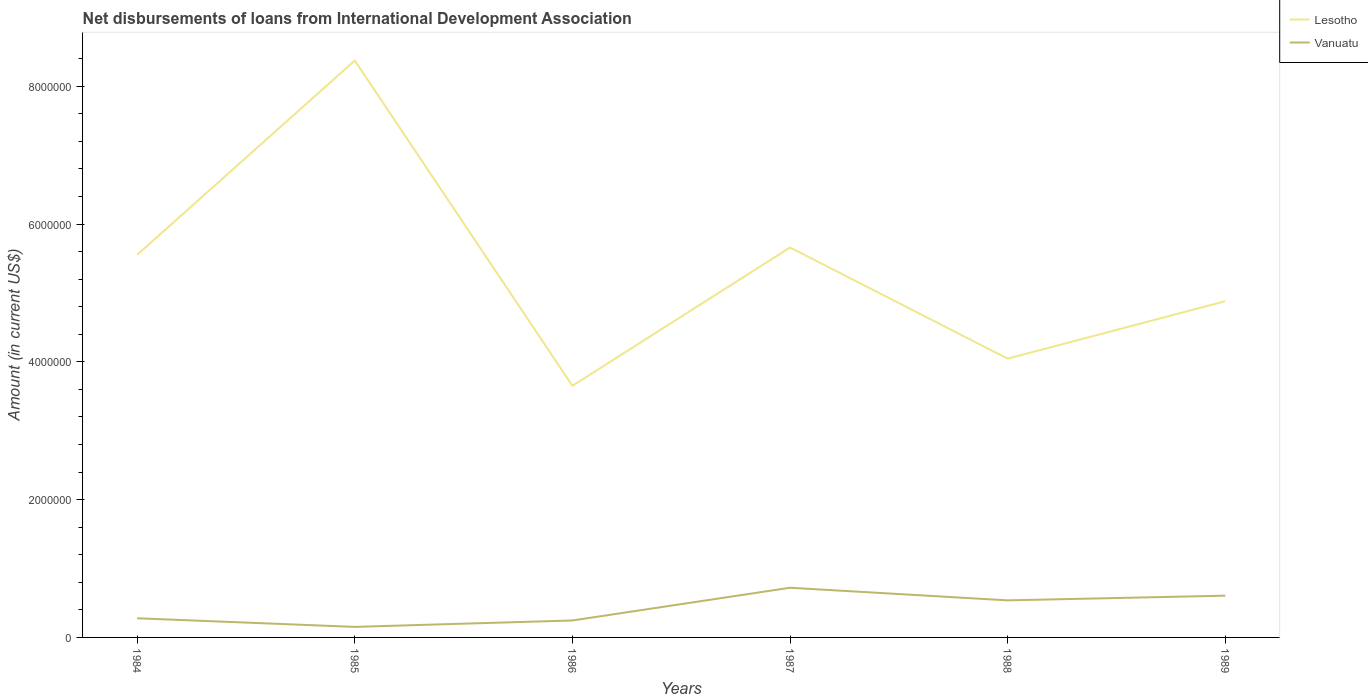Does the line corresponding to Lesotho intersect with the line corresponding to Vanuatu?
Your response must be concise. No. Is the number of lines equal to the number of legend labels?
Your response must be concise. Yes. Across all years, what is the maximum amount of loans disbursed in Vanuatu?
Your answer should be compact. 1.53e+05. What is the total amount of loans disbursed in Lesotho in the graph?
Your answer should be very brief. 4.72e+06. What is the difference between the highest and the second highest amount of loans disbursed in Lesotho?
Ensure brevity in your answer.  4.72e+06. What is the difference between the highest and the lowest amount of loans disbursed in Vanuatu?
Ensure brevity in your answer.  3. Is the amount of loans disbursed in Vanuatu strictly greater than the amount of loans disbursed in Lesotho over the years?
Offer a terse response. Yes. How many lines are there?
Offer a terse response. 2. How many years are there in the graph?
Your answer should be compact. 6. Are the values on the major ticks of Y-axis written in scientific E-notation?
Your answer should be compact. No. What is the title of the graph?
Offer a very short reply. Net disbursements of loans from International Development Association. What is the Amount (in current US$) in Lesotho in 1984?
Your answer should be compact. 5.55e+06. What is the Amount (in current US$) of Vanuatu in 1984?
Offer a very short reply. 2.78e+05. What is the Amount (in current US$) of Lesotho in 1985?
Provide a short and direct response. 8.37e+06. What is the Amount (in current US$) in Vanuatu in 1985?
Your answer should be very brief. 1.53e+05. What is the Amount (in current US$) in Lesotho in 1986?
Your answer should be compact. 3.65e+06. What is the Amount (in current US$) in Vanuatu in 1986?
Make the answer very short. 2.46e+05. What is the Amount (in current US$) in Lesotho in 1987?
Provide a short and direct response. 5.66e+06. What is the Amount (in current US$) in Vanuatu in 1987?
Provide a succinct answer. 7.21e+05. What is the Amount (in current US$) in Lesotho in 1988?
Keep it short and to the point. 4.05e+06. What is the Amount (in current US$) of Vanuatu in 1988?
Offer a terse response. 5.38e+05. What is the Amount (in current US$) of Lesotho in 1989?
Make the answer very short. 4.88e+06. What is the Amount (in current US$) in Vanuatu in 1989?
Your answer should be very brief. 6.06e+05. Across all years, what is the maximum Amount (in current US$) of Lesotho?
Provide a short and direct response. 8.37e+06. Across all years, what is the maximum Amount (in current US$) in Vanuatu?
Provide a short and direct response. 7.21e+05. Across all years, what is the minimum Amount (in current US$) of Lesotho?
Provide a succinct answer. 3.65e+06. Across all years, what is the minimum Amount (in current US$) of Vanuatu?
Give a very brief answer. 1.53e+05. What is the total Amount (in current US$) in Lesotho in the graph?
Provide a short and direct response. 3.22e+07. What is the total Amount (in current US$) in Vanuatu in the graph?
Your response must be concise. 2.54e+06. What is the difference between the Amount (in current US$) in Lesotho in 1984 and that in 1985?
Your answer should be compact. -2.82e+06. What is the difference between the Amount (in current US$) in Vanuatu in 1984 and that in 1985?
Offer a very short reply. 1.25e+05. What is the difference between the Amount (in current US$) of Lesotho in 1984 and that in 1986?
Your answer should be compact. 1.90e+06. What is the difference between the Amount (in current US$) in Vanuatu in 1984 and that in 1986?
Offer a very short reply. 3.20e+04. What is the difference between the Amount (in current US$) of Lesotho in 1984 and that in 1987?
Make the answer very short. -1.06e+05. What is the difference between the Amount (in current US$) in Vanuatu in 1984 and that in 1987?
Offer a very short reply. -4.43e+05. What is the difference between the Amount (in current US$) of Lesotho in 1984 and that in 1988?
Offer a very short reply. 1.51e+06. What is the difference between the Amount (in current US$) in Vanuatu in 1984 and that in 1988?
Your response must be concise. -2.60e+05. What is the difference between the Amount (in current US$) of Lesotho in 1984 and that in 1989?
Ensure brevity in your answer.  6.73e+05. What is the difference between the Amount (in current US$) in Vanuatu in 1984 and that in 1989?
Make the answer very short. -3.28e+05. What is the difference between the Amount (in current US$) in Lesotho in 1985 and that in 1986?
Make the answer very short. 4.72e+06. What is the difference between the Amount (in current US$) of Vanuatu in 1985 and that in 1986?
Your answer should be very brief. -9.30e+04. What is the difference between the Amount (in current US$) in Lesotho in 1985 and that in 1987?
Offer a very short reply. 2.71e+06. What is the difference between the Amount (in current US$) of Vanuatu in 1985 and that in 1987?
Your answer should be compact. -5.68e+05. What is the difference between the Amount (in current US$) in Lesotho in 1985 and that in 1988?
Your answer should be very brief. 4.33e+06. What is the difference between the Amount (in current US$) in Vanuatu in 1985 and that in 1988?
Offer a terse response. -3.85e+05. What is the difference between the Amount (in current US$) of Lesotho in 1985 and that in 1989?
Provide a succinct answer. 3.49e+06. What is the difference between the Amount (in current US$) in Vanuatu in 1985 and that in 1989?
Ensure brevity in your answer.  -4.53e+05. What is the difference between the Amount (in current US$) in Lesotho in 1986 and that in 1987?
Ensure brevity in your answer.  -2.01e+06. What is the difference between the Amount (in current US$) in Vanuatu in 1986 and that in 1987?
Your answer should be compact. -4.75e+05. What is the difference between the Amount (in current US$) in Lesotho in 1986 and that in 1988?
Ensure brevity in your answer.  -3.94e+05. What is the difference between the Amount (in current US$) of Vanuatu in 1986 and that in 1988?
Your answer should be compact. -2.92e+05. What is the difference between the Amount (in current US$) in Lesotho in 1986 and that in 1989?
Ensure brevity in your answer.  -1.23e+06. What is the difference between the Amount (in current US$) in Vanuatu in 1986 and that in 1989?
Ensure brevity in your answer.  -3.60e+05. What is the difference between the Amount (in current US$) in Lesotho in 1987 and that in 1988?
Ensure brevity in your answer.  1.61e+06. What is the difference between the Amount (in current US$) in Vanuatu in 1987 and that in 1988?
Your answer should be very brief. 1.83e+05. What is the difference between the Amount (in current US$) in Lesotho in 1987 and that in 1989?
Your response must be concise. 7.79e+05. What is the difference between the Amount (in current US$) of Vanuatu in 1987 and that in 1989?
Make the answer very short. 1.15e+05. What is the difference between the Amount (in current US$) of Lesotho in 1988 and that in 1989?
Offer a very short reply. -8.34e+05. What is the difference between the Amount (in current US$) in Vanuatu in 1988 and that in 1989?
Give a very brief answer. -6.80e+04. What is the difference between the Amount (in current US$) in Lesotho in 1984 and the Amount (in current US$) in Vanuatu in 1985?
Offer a very short reply. 5.40e+06. What is the difference between the Amount (in current US$) of Lesotho in 1984 and the Amount (in current US$) of Vanuatu in 1986?
Make the answer very short. 5.31e+06. What is the difference between the Amount (in current US$) of Lesotho in 1984 and the Amount (in current US$) of Vanuatu in 1987?
Your response must be concise. 4.83e+06. What is the difference between the Amount (in current US$) of Lesotho in 1984 and the Amount (in current US$) of Vanuatu in 1988?
Your answer should be very brief. 5.02e+06. What is the difference between the Amount (in current US$) of Lesotho in 1984 and the Amount (in current US$) of Vanuatu in 1989?
Keep it short and to the point. 4.95e+06. What is the difference between the Amount (in current US$) in Lesotho in 1985 and the Amount (in current US$) in Vanuatu in 1986?
Provide a short and direct response. 8.13e+06. What is the difference between the Amount (in current US$) in Lesotho in 1985 and the Amount (in current US$) in Vanuatu in 1987?
Give a very brief answer. 7.65e+06. What is the difference between the Amount (in current US$) in Lesotho in 1985 and the Amount (in current US$) in Vanuatu in 1988?
Your answer should be compact. 7.83e+06. What is the difference between the Amount (in current US$) of Lesotho in 1985 and the Amount (in current US$) of Vanuatu in 1989?
Give a very brief answer. 7.77e+06. What is the difference between the Amount (in current US$) of Lesotho in 1986 and the Amount (in current US$) of Vanuatu in 1987?
Your answer should be compact. 2.93e+06. What is the difference between the Amount (in current US$) of Lesotho in 1986 and the Amount (in current US$) of Vanuatu in 1988?
Provide a succinct answer. 3.11e+06. What is the difference between the Amount (in current US$) of Lesotho in 1986 and the Amount (in current US$) of Vanuatu in 1989?
Offer a very short reply. 3.05e+06. What is the difference between the Amount (in current US$) of Lesotho in 1987 and the Amount (in current US$) of Vanuatu in 1988?
Provide a short and direct response. 5.12e+06. What is the difference between the Amount (in current US$) of Lesotho in 1987 and the Amount (in current US$) of Vanuatu in 1989?
Your answer should be compact. 5.05e+06. What is the difference between the Amount (in current US$) in Lesotho in 1988 and the Amount (in current US$) in Vanuatu in 1989?
Keep it short and to the point. 3.44e+06. What is the average Amount (in current US$) of Lesotho per year?
Ensure brevity in your answer.  5.36e+06. What is the average Amount (in current US$) in Vanuatu per year?
Ensure brevity in your answer.  4.24e+05. In the year 1984, what is the difference between the Amount (in current US$) in Lesotho and Amount (in current US$) in Vanuatu?
Your answer should be compact. 5.28e+06. In the year 1985, what is the difference between the Amount (in current US$) in Lesotho and Amount (in current US$) in Vanuatu?
Ensure brevity in your answer.  8.22e+06. In the year 1986, what is the difference between the Amount (in current US$) in Lesotho and Amount (in current US$) in Vanuatu?
Make the answer very short. 3.41e+06. In the year 1987, what is the difference between the Amount (in current US$) of Lesotho and Amount (in current US$) of Vanuatu?
Provide a succinct answer. 4.94e+06. In the year 1988, what is the difference between the Amount (in current US$) in Lesotho and Amount (in current US$) in Vanuatu?
Ensure brevity in your answer.  3.51e+06. In the year 1989, what is the difference between the Amount (in current US$) of Lesotho and Amount (in current US$) of Vanuatu?
Your answer should be compact. 4.27e+06. What is the ratio of the Amount (in current US$) of Lesotho in 1984 to that in 1985?
Your answer should be very brief. 0.66. What is the ratio of the Amount (in current US$) of Vanuatu in 1984 to that in 1985?
Keep it short and to the point. 1.82. What is the ratio of the Amount (in current US$) in Lesotho in 1984 to that in 1986?
Make the answer very short. 1.52. What is the ratio of the Amount (in current US$) of Vanuatu in 1984 to that in 1986?
Provide a short and direct response. 1.13. What is the ratio of the Amount (in current US$) of Lesotho in 1984 to that in 1987?
Offer a very short reply. 0.98. What is the ratio of the Amount (in current US$) in Vanuatu in 1984 to that in 1987?
Ensure brevity in your answer.  0.39. What is the ratio of the Amount (in current US$) of Lesotho in 1984 to that in 1988?
Make the answer very short. 1.37. What is the ratio of the Amount (in current US$) in Vanuatu in 1984 to that in 1988?
Offer a terse response. 0.52. What is the ratio of the Amount (in current US$) of Lesotho in 1984 to that in 1989?
Make the answer very short. 1.14. What is the ratio of the Amount (in current US$) in Vanuatu in 1984 to that in 1989?
Make the answer very short. 0.46. What is the ratio of the Amount (in current US$) in Lesotho in 1985 to that in 1986?
Keep it short and to the point. 2.29. What is the ratio of the Amount (in current US$) of Vanuatu in 1985 to that in 1986?
Provide a short and direct response. 0.62. What is the ratio of the Amount (in current US$) in Lesotho in 1985 to that in 1987?
Your response must be concise. 1.48. What is the ratio of the Amount (in current US$) in Vanuatu in 1985 to that in 1987?
Your response must be concise. 0.21. What is the ratio of the Amount (in current US$) in Lesotho in 1985 to that in 1988?
Your answer should be very brief. 2.07. What is the ratio of the Amount (in current US$) in Vanuatu in 1985 to that in 1988?
Your response must be concise. 0.28. What is the ratio of the Amount (in current US$) in Lesotho in 1985 to that in 1989?
Your response must be concise. 1.72. What is the ratio of the Amount (in current US$) in Vanuatu in 1985 to that in 1989?
Offer a terse response. 0.25. What is the ratio of the Amount (in current US$) of Lesotho in 1986 to that in 1987?
Make the answer very short. 0.65. What is the ratio of the Amount (in current US$) of Vanuatu in 1986 to that in 1987?
Keep it short and to the point. 0.34. What is the ratio of the Amount (in current US$) of Lesotho in 1986 to that in 1988?
Ensure brevity in your answer.  0.9. What is the ratio of the Amount (in current US$) of Vanuatu in 1986 to that in 1988?
Provide a succinct answer. 0.46. What is the ratio of the Amount (in current US$) of Lesotho in 1986 to that in 1989?
Give a very brief answer. 0.75. What is the ratio of the Amount (in current US$) in Vanuatu in 1986 to that in 1989?
Offer a very short reply. 0.41. What is the ratio of the Amount (in current US$) of Lesotho in 1987 to that in 1988?
Give a very brief answer. 1.4. What is the ratio of the Amount (in current US$) of Vanuatu in 1987 to that in 1988?
Your answer should be very brief. 1.34. What is the ratio of the Amount (in current US$) of Lesotho in 1987 to that in 1989?
Provide a short and direct response. 1.16. What is the ratio of the Amount (in current US$) of Vanuatu in 1987 to that in 1989?
Offer a very short reply. 1.19. What is the ratio of the Amount (in current US$) of Lesotho in 1988 to that in 1989?
Ensure brevity in your answer.  0.83. What is the ratio of the Amount (in current US$) in Vanuatu in 1988 to that in 1989?
Give a very brief answer. 0.89. What is the difference between the highest and the second highest Amount (in current US$) in Lesotho?
Give a very brief answer. 2.71e+06. What is the difference between the highest and the second highest Amount (in current US$) in Vanuatu?
Offer a terse response. 1.15e+05. What is the difference between the highest and the lowest Amount (in current US$) in Lesotho?
Your answer should be very brief. 4.72e+06. What is the difference between the highest and the lowest Amount (in current US$) in Vanuatu?
Provide a short and direct response. 5.68e+05. 